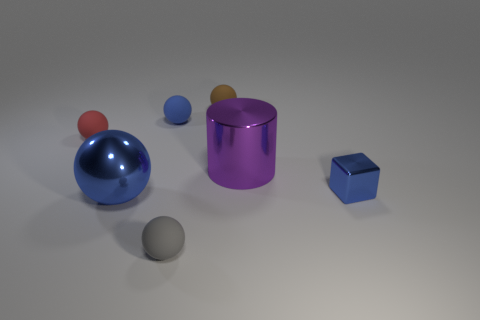Subtract all brown balls. How many balls are left? 4 Subtract all red balls. How many balls are left? 4 Subtract all cyan balls. Subtract all brown cylinders. How many balls are left? 5 Add 1 big red matte things. How many objects exist? 8 Subtract all cylinders. How many objects are left? 6 Subtract 0 gray cubes. How many objects are left? 7 Subtract all large brown rubber blocks. Subtract all large things. How many objects are left? 5 Add 5 big blue metal objects. How many big blue metal objects are left? 6 Add 6 blue matte balls. How many blue matte balls exist? 7 